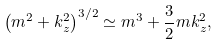Convert formula to latex. <formula><loc_0><loc_0><loc_500><loc_500>\left ( m ^ { 2 } + k _ { z } ^ { 2 } \right ) ^ { 3 / 2 } \simeq m ^ { 3 } + \frac { 3 } { 2 } m k _ { z } ^ { 2 } ,</formula> 